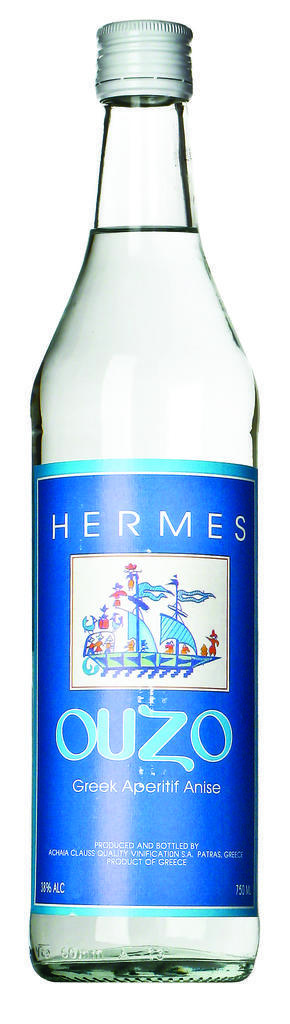What is contained in the bottle that is visible in the image? There is a drink in the bottle that is visible in the image. Is there any additional information or decoration on the bottle? Yes, the bottle has a sticker on it. What is the color of the background in the image? The background of the image is white. What type of base is supporting the bottle in the image? There is no base visible in the image, as the bottle appears to be standing on its own. 